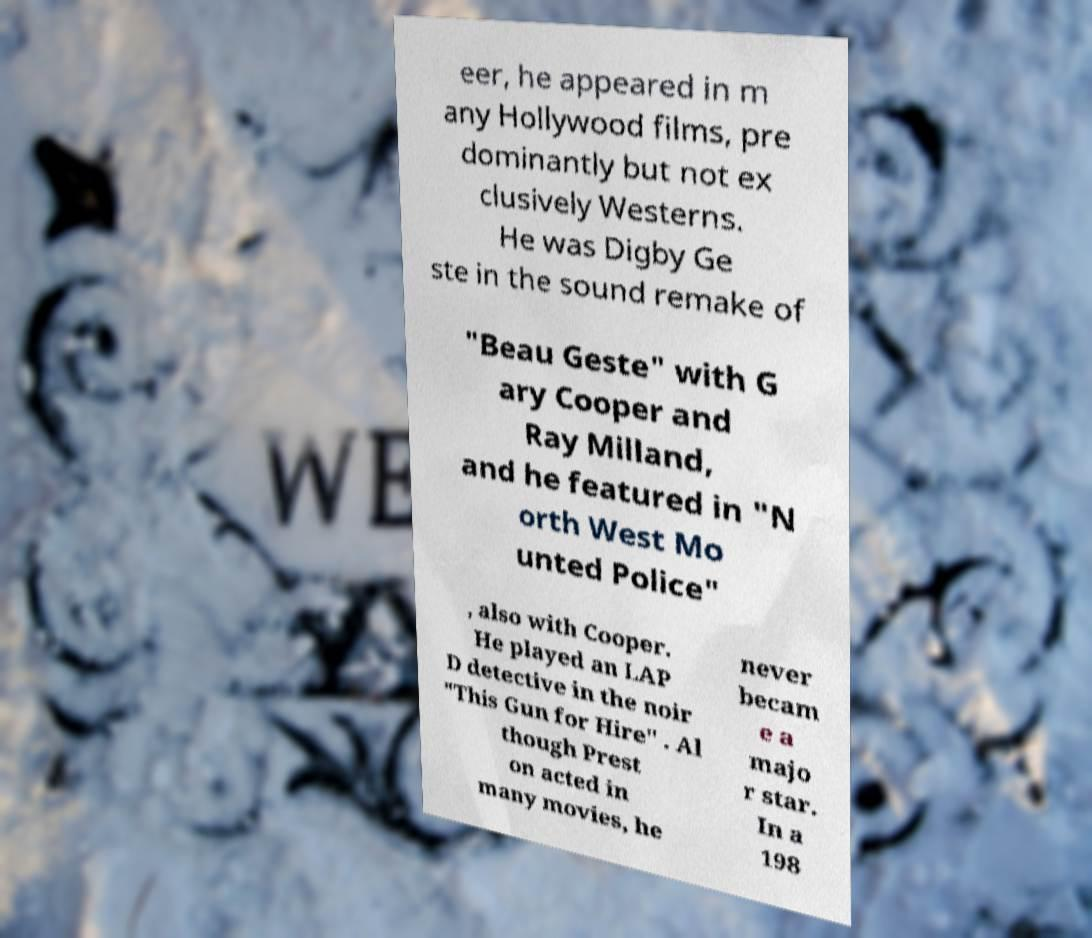I need the written content from this picture converted into text. Can you do that? eer, he appeared in m any Hollywood films, pre dominantly but not ex clusively Westerns. He was Digby Ge ste in the sound remake of "Beau Geste" with G ary Cooper and Ray Milland, and he featured in "N orth West Mo unted Police" , also with Cooper. He played an LAP D detective in the noir "This Gun for Hire" . Al though Prest on acted in many movies, he never becam e a majo r star. In a 198 